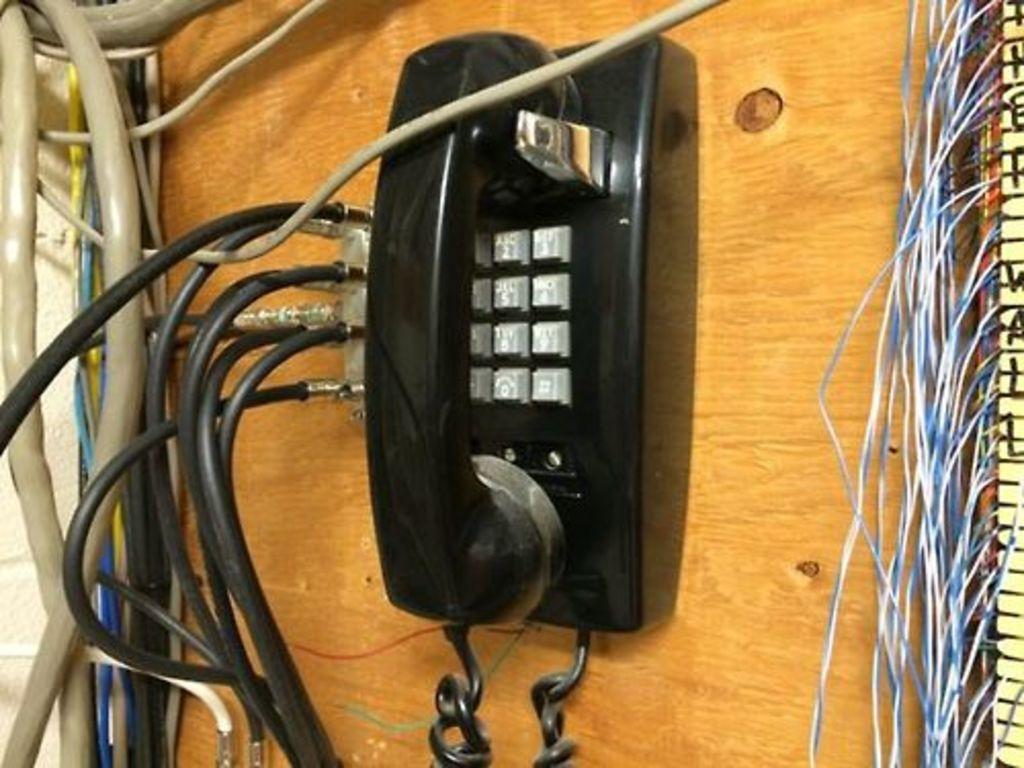Can you describe this image briefly? In this image we can see a wooden surface, telephone and cables. 